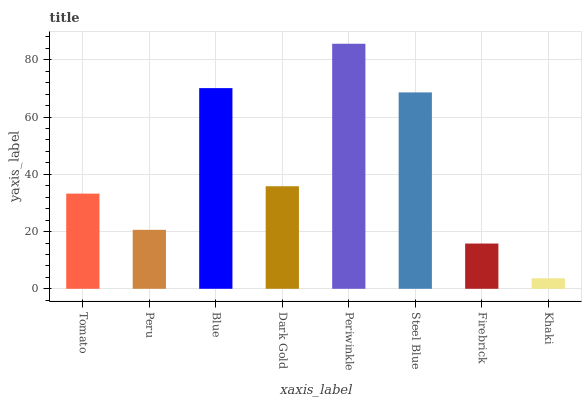Is Khaki the minimum?
Answer yes or no. Yes. Is Periwinkle the maximum?
Answer yes or no. Yes. Is Peru the minimum?
Answer yes or no. No. Is Peru the maximum?
Answer yes or no. No. Is Tomato greater than Peru?
Answer yes or no. Yes. Is Peru less than Tomato?
Answer yes or no. Yes. Is Peru greater than Tomato?
Answer yes or no. No. Is Tomato less than Peru?
Answer yes or no. No. Is Dark Gold the high median?
Answer yes or no. Yes. Is Tomato the low median?
Answer yes or no. Yes. Is Periwinkle the high median?
Answer yes or no. No. Is Periwinkle the low median?
Answer yes or no. No. 